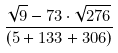<formula> <loc_0><loc_0><loc_500><loc_500>\frac { \sqrt { 9 } - 7 3 \cdot \sqrt { 2 7 6 } } { ( 5 + 1 3 3 + 3 0 6 ) }</formula> 